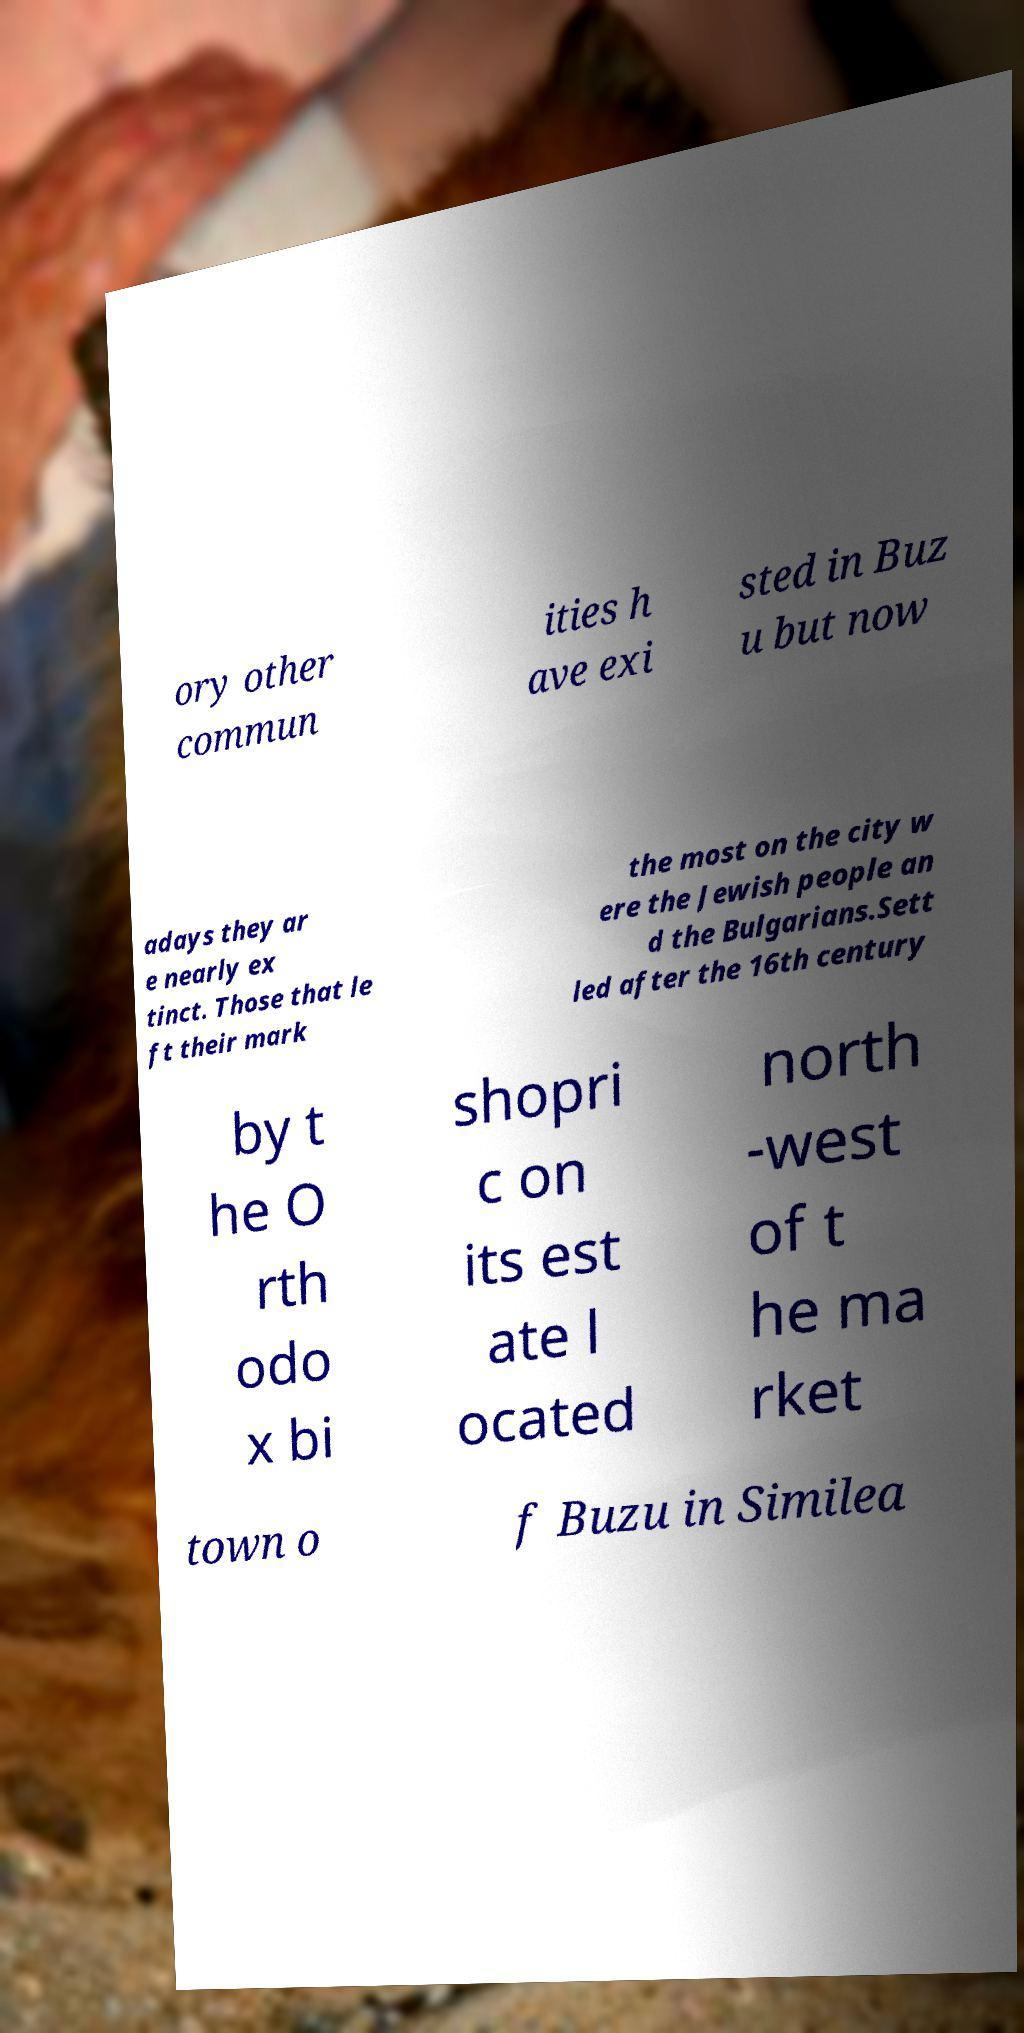Please identify and transcribe the text found in this image. ory other commun ities h ave exi sted in Buz u but now adays they ar e nearly ex tinct. Those that le ft their mark the most on the city w ere the Jewish people an d the Bulgarians.Sett led after the 16th century by t he O rth odo x bi shopri c on its est ate l ocated north -west of t he ma rket town o f Buzu in Similea 